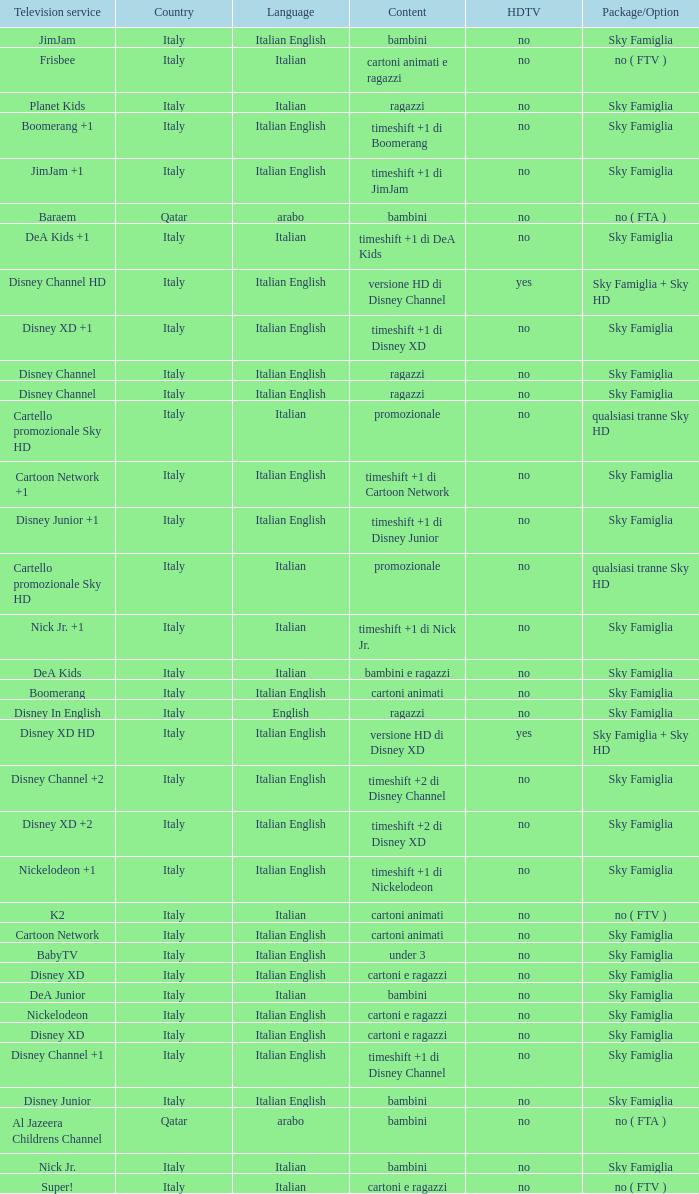What is the HDTV when the Package/Option is sky famiglia, and a Television service of boomerang +1? No. 